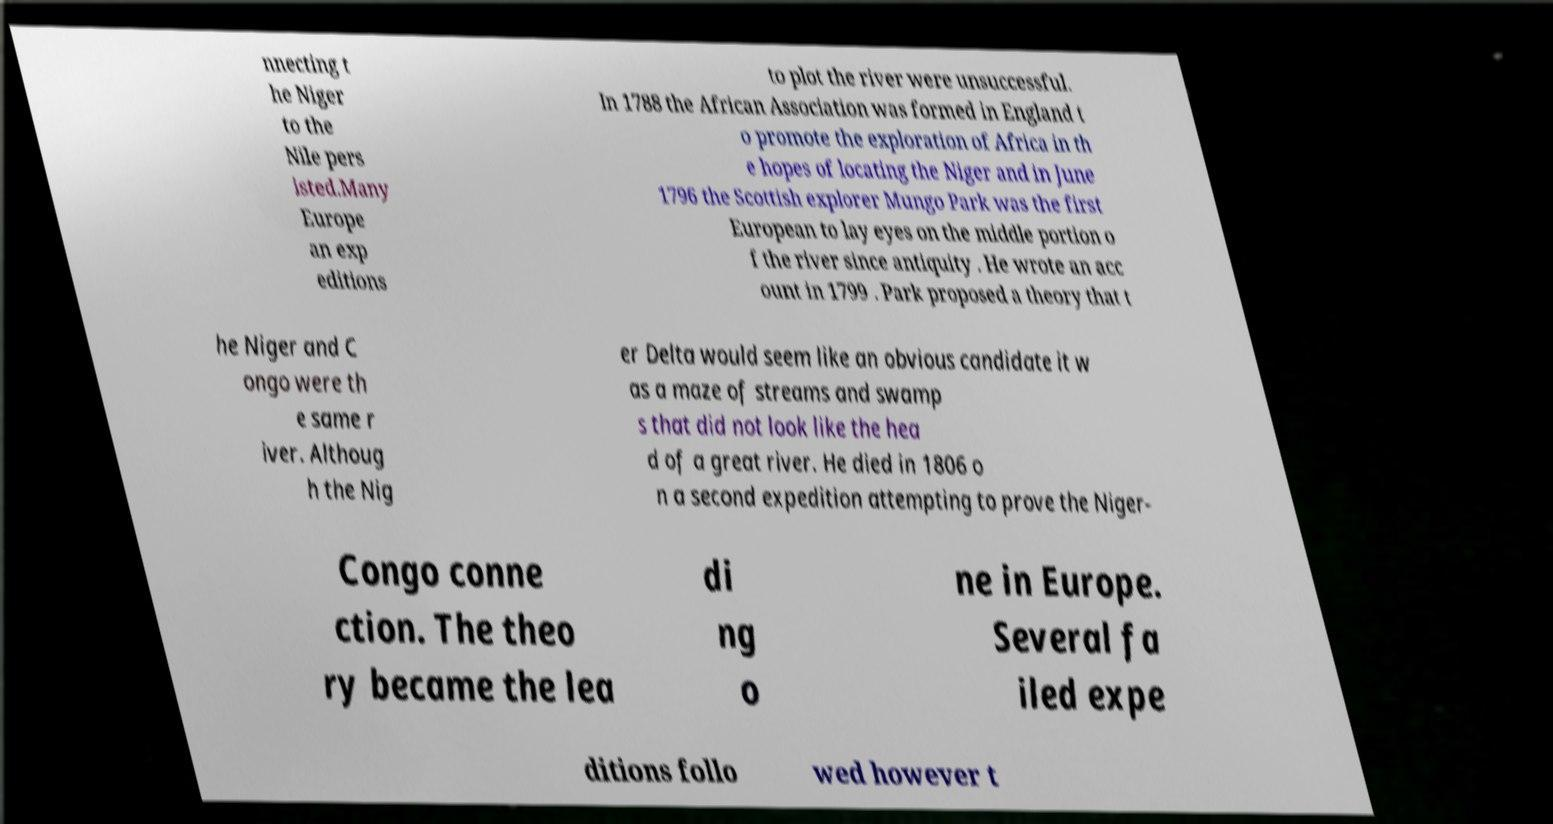I need the written content from this picture converted into text. Can you do that? nnecting t he Niger to the Nile pers isted.Many Europe an exp editions to plot the river were unsuccessful. In 1788 the African Association was formed in England t o promote the exploration of Africa in th e hopes of locating the Niger and in June 1796 the Scottish explorer Mungo Park was the first European to lay eyes on the middle portion o f the river since antiquity . He wrote an acc ount in 1799 . Park proposed a theory that t he Niger and C ongo were th e same r iver. Althoug h the Nig er Delta would seem like an obvious candidate it w as a maze of streams and swamp s that did not look like the hea d of a great river. He died in 1806 o n a second expedition attempting to prove the Niger- Congo conne ction. The theo ry became the lea di ng o ne in Europe. Several fa iled expe ditions follo wed however t 